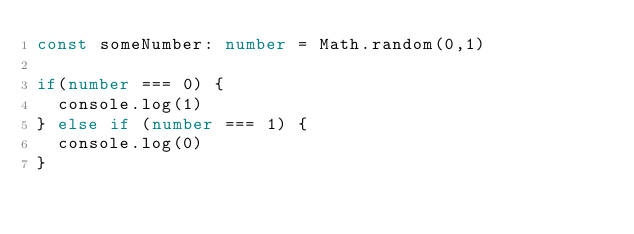Convert code to text. <code><loc_0><loc_0><loc_500><loc_500><_TypeScript_>const someNumber: number = Math.random(0,1)

if(number === 0) {
  console.log(1)
} else if (number === 1) {
  console.log(0)
}</code> 